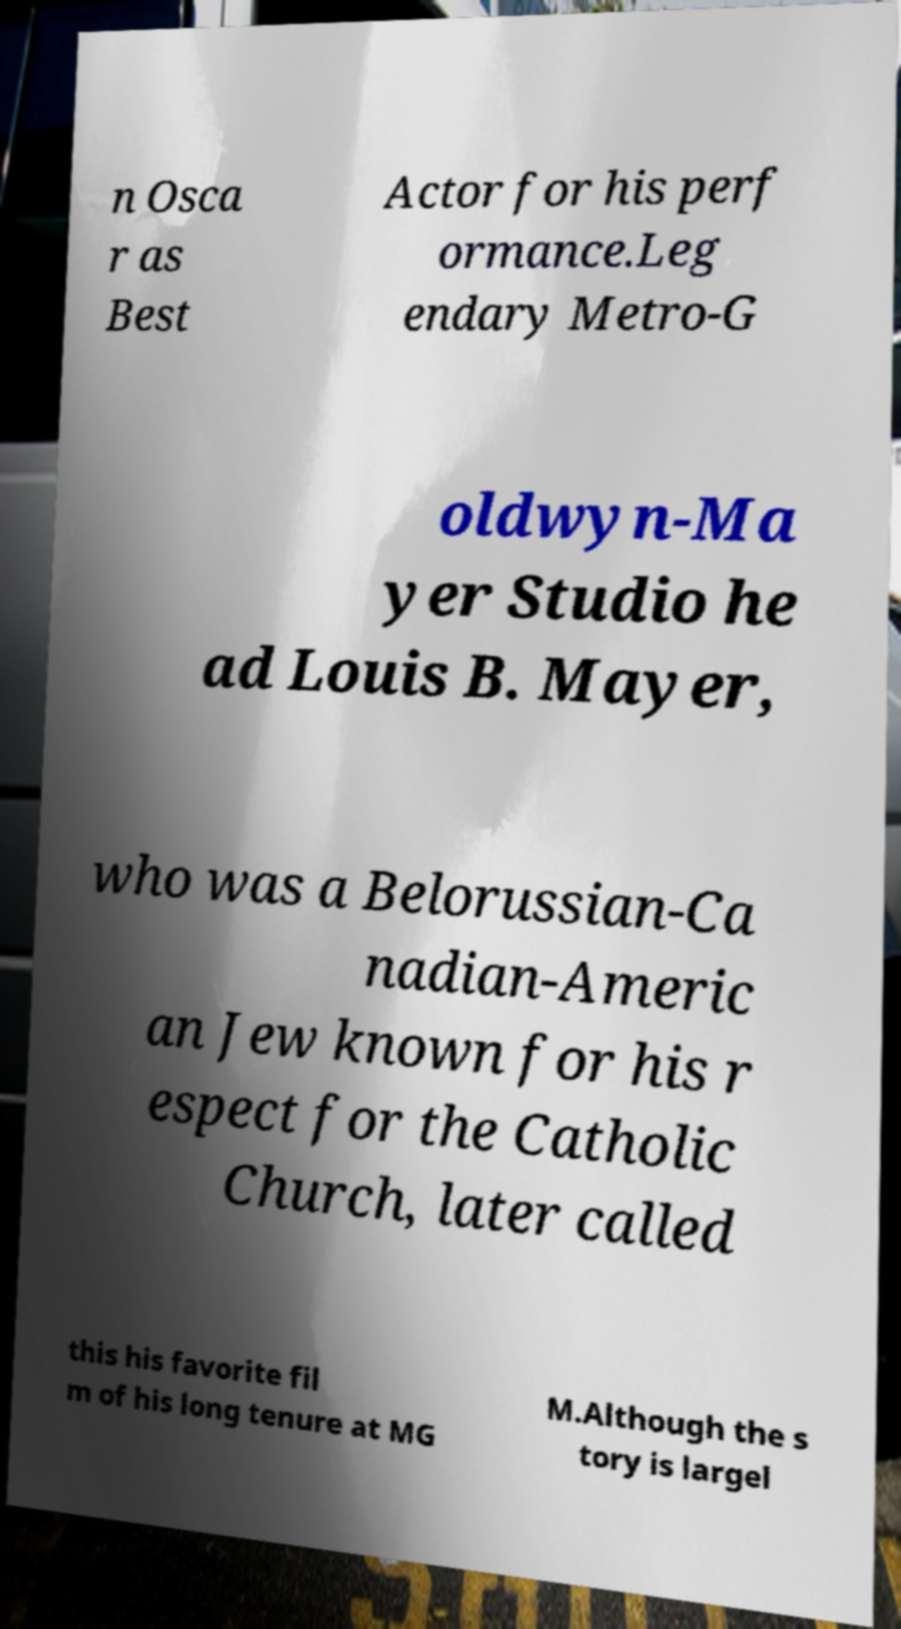Can you read and provide the text displayed in the image?This photo seems to have some interesting text. Can you extract and type it out for me? n Osca r as Best Actor for his perf ormance.Leg endary Metro-G oldwyn-Ma yer Studio he ad Louis B. Mayer, who was a Belorussian-Ca nadian-Americ an Jew known for his r espect for the Catholic Church, later called this his favorite fil m of his long tenure at MG M.Although the s tory is largel 